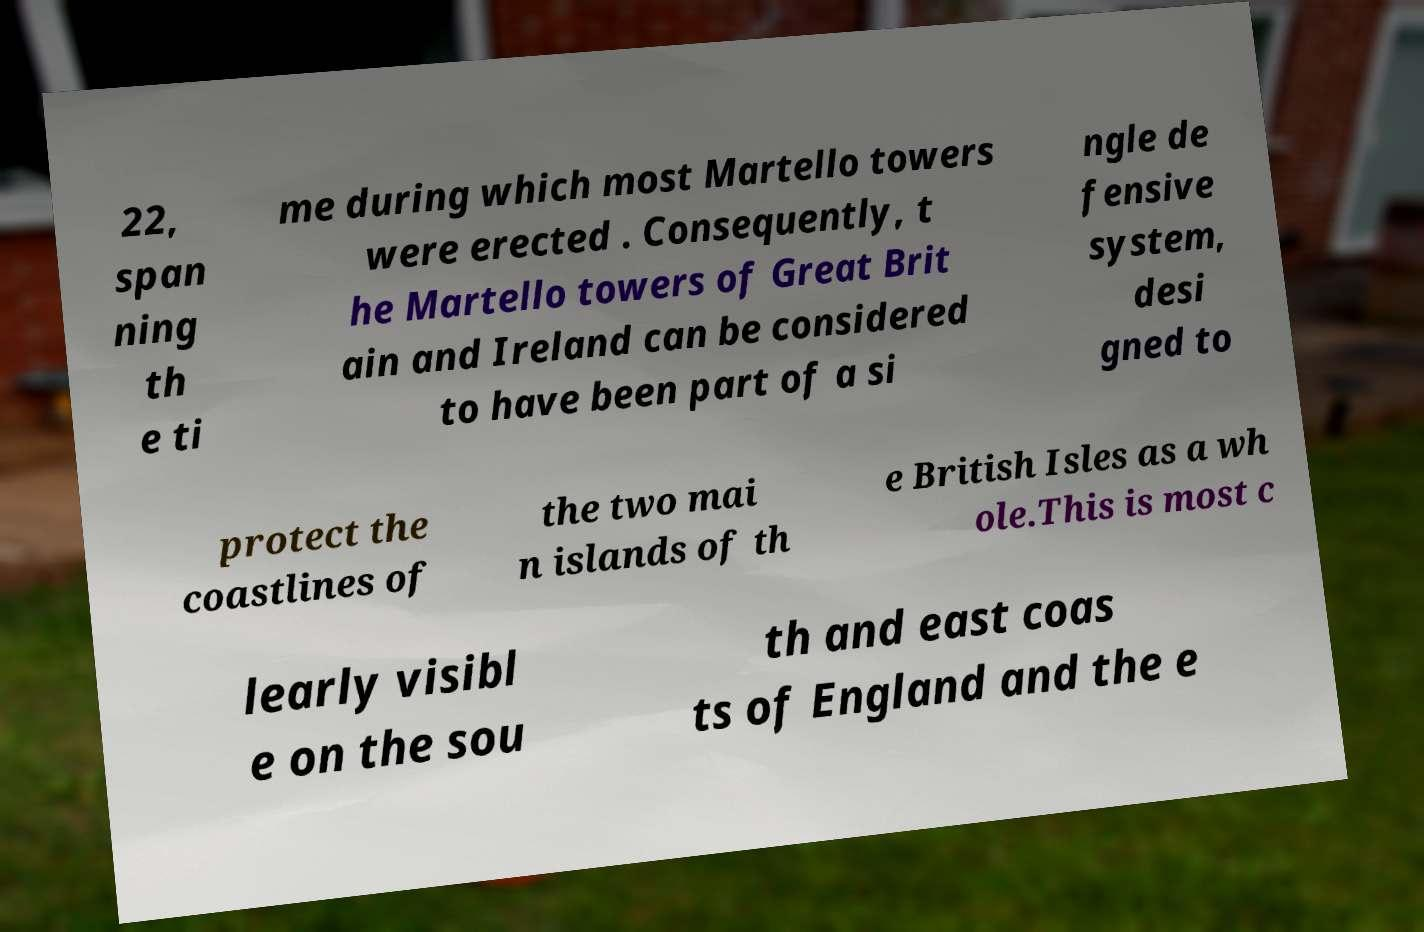What messages or text are displayed in this image? I need them in a readable, typed format. 22, span ning th e ti me during which most Martello towers were erected . Consequently, t he Martello towers of Great Brit ain and Ireland can be considered to have been part of a si ngle de fensive system, desi gned to protect the coastlines of the two mai n islands of th e British Isles as a wh ole.This is most c learly visibl e on the sou th and east coas ts of England and the e 